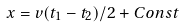<formula> <loc_0><loc_0><loc_500><loc_500>x = v ( t _ { 1 } - t _ { 2 } ) / 2 + C o n s t</formula> 